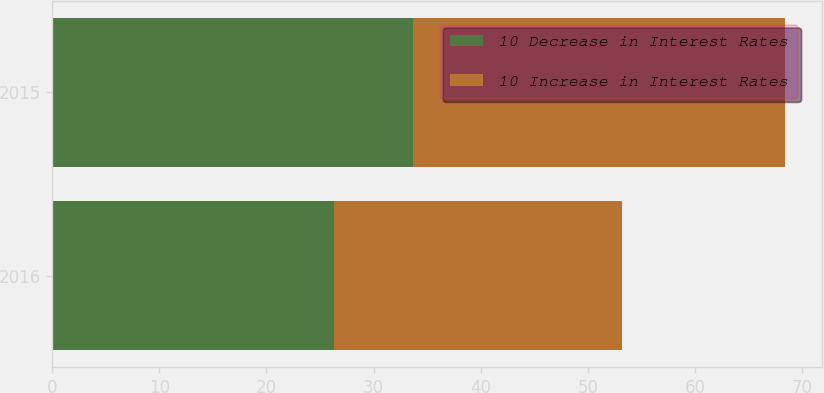Convert chart to OTSL. <chart><loc_0><loc_0><loc_500><loc_500><stacked_bar_chart><ecel><fcel>2016<fcel>2015<nl><fcel>10 Decrease in Interest Rates<fcel>26.3<fcel>33.7<nl><fcel>10 Increase in Interest Rates<fcel>26.9<fcel>34.7<nl></chart> 